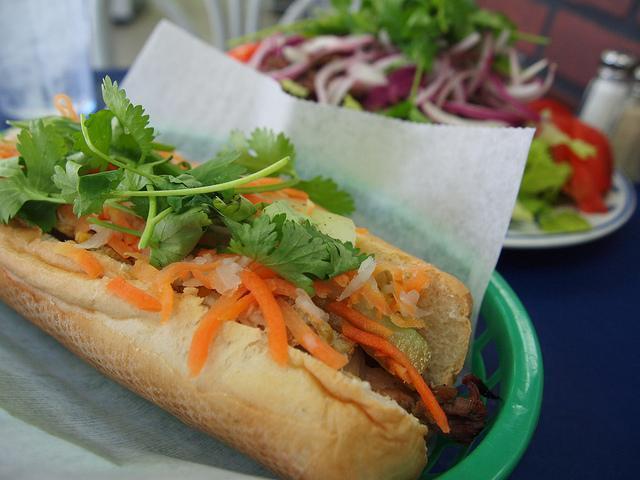Is the given caption "The bowl is in front of the sandwich." fitting for the image?
Answer yes or no. No. 